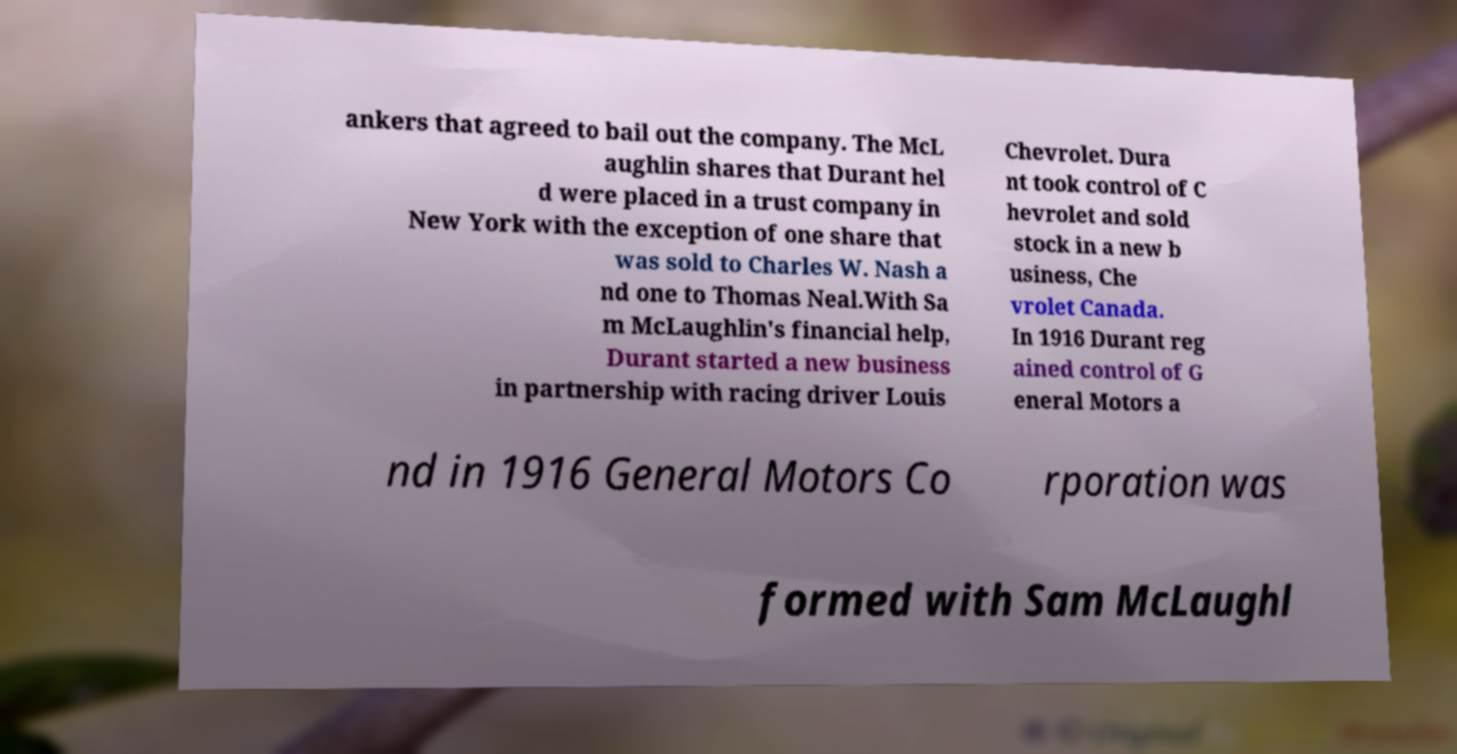Can you read and provide the text displayed in the image?This photo seems to have some interesting text. Can you extract and type it out for me? ankers that agreed to bail out the company. The McL aughlin shares that Durant hel d were placed in a trust company in New York with the exception of one share that was sold to Charles W. Nash a nd one to Thomas Neal.With Sa m McLaughlin's financial help, Durant started a new business in partnership with racing driver Louis Chevrolet. Dura nt took control of C hevrolet and sold stock in a new b usiness, Che vrolet Canada. In 1916 Durant reg ained control of G eneral Motors a nd in 1916 General Motors Co rporation was formed with Sam McLaughl 